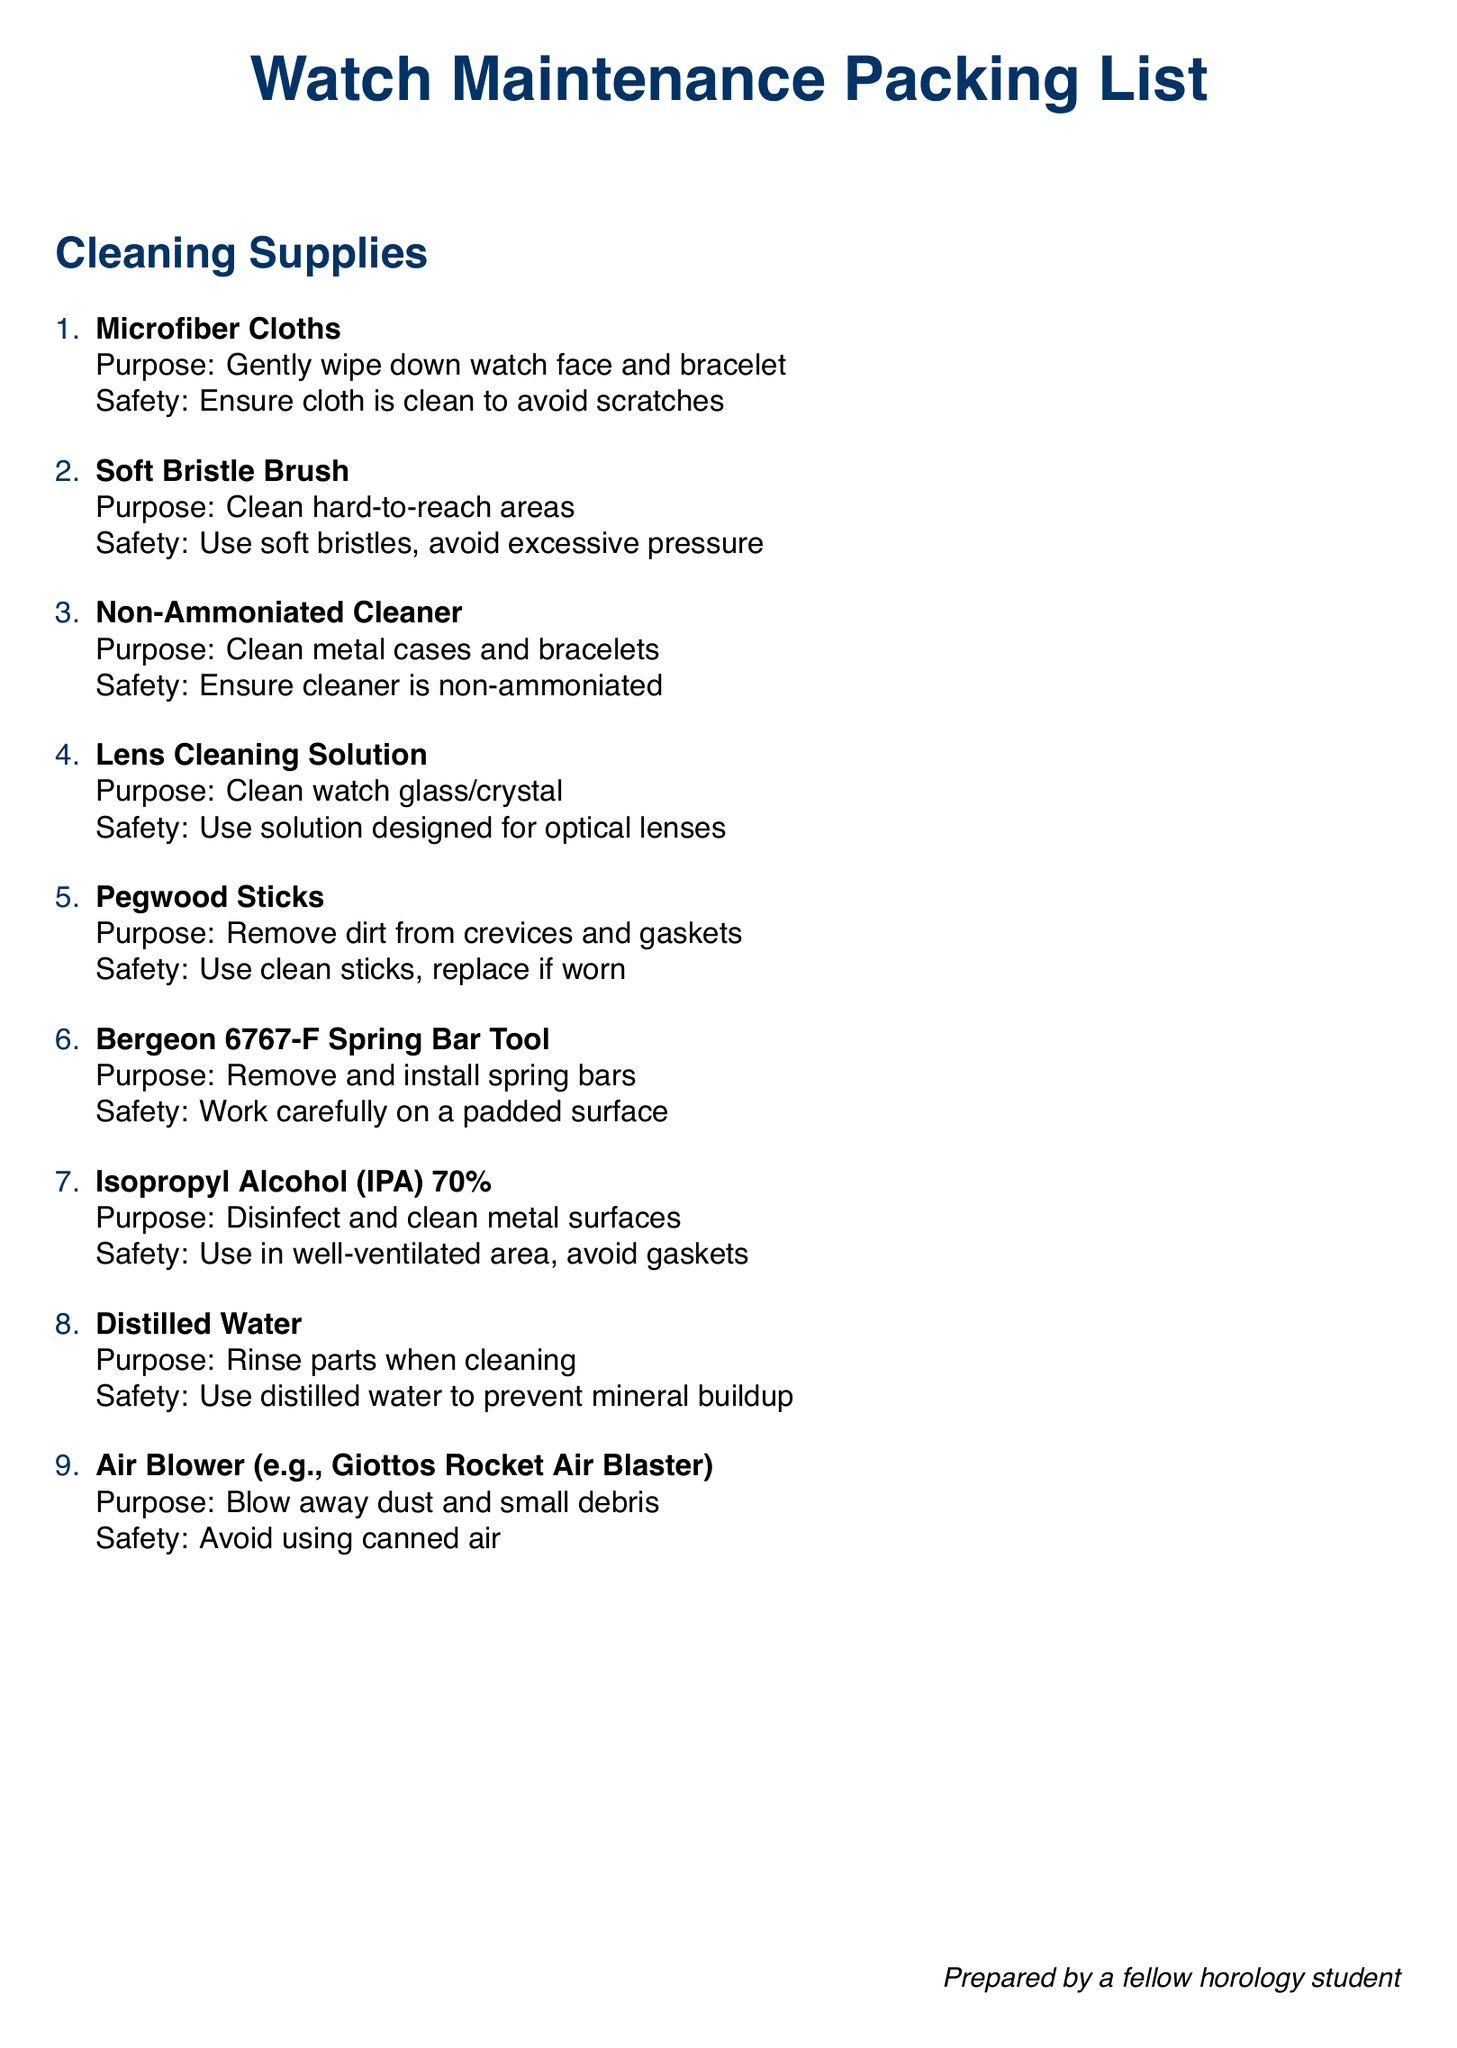What is the purpose of microfiber cloths? The purpose of microfiber cloths is to gently wipe down the watch face and bracelet.
Answer: Gently wipe down watch face and bracelet What should be ensured when using a soft bristle brush? It should be ensured that soft bristles are used and that excessive pressure is avoided.
Answer: Soft bristles, avoid excessive pressure What is the safety precaution for using isopropyl alcohol? The safety precaution is to use it in a well-ventilated area and avoid gaskets.
Answer: Well-ventilated area, avoid gaskets How many cleaning supplies are listed in total? The total number of cleaning supplies listed can be counted from the document. There are 8 items enumerated here.
Answer: 8 What is the purpose of distilled water in the cleaning process? The purpose of distilled water is to rinse parts when cleaning.
Answer: Rinse parts when cleaning Why should a non-ammoniated cleaner be used? A non-ammoniated cleaner should be used to avoid damaging metal surfaces.
Answer: Avoid damaging metal surfaces What type of surface should the Bergeon tool be used on? The Bergeon tool should be used carefully on a padded surface.
Answer: Padded surface What type of air blower is not recommended for use? Canned air is not recommended for use when blowing away dust and debris.
Answer: Canned air 